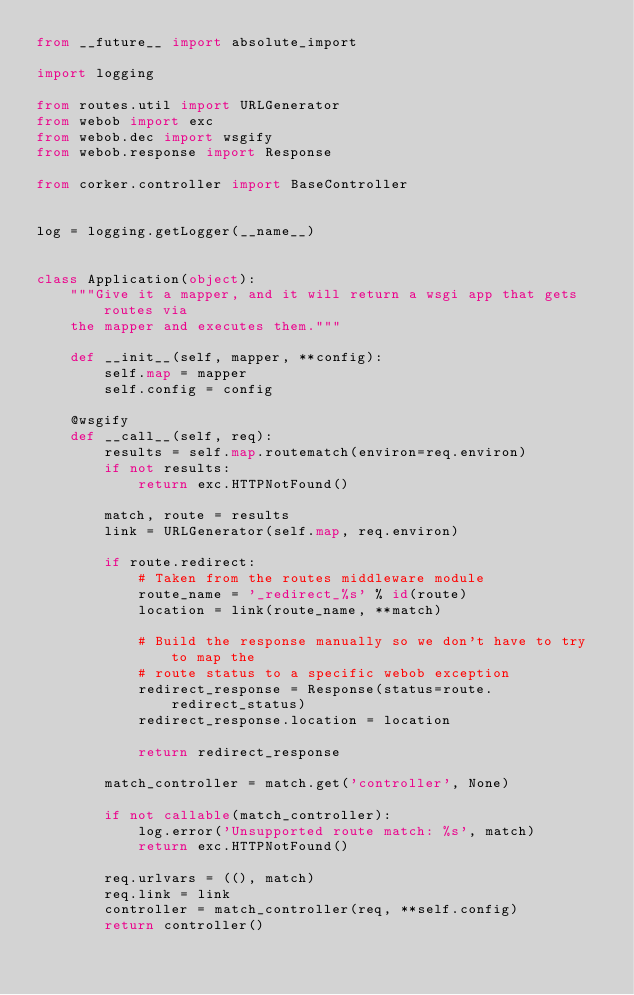<code> <loc_0><loc_0><loc_500><loc_500><_Python_>from __future__ import absolute_import

import logging

from routes.util import URLGenerator
from webob import exc
from webob.dec import wsgify
from webob.response import Response

from corker.controller import BaseController


log = logging.getLogger(__name__)


class Application(object):
    """Give it a mapper, and it will return a wsgi app that gets routes via
    the mapper and executes them."""

    def __init__(self, mapper, **config):
        self.map = mapper
        self.config = config

    @wsgify
    def __call__(self, req):
        results = self.map.routematch(environ=req.environ)
        if not results:
            return exc.HTTPNotFound()

        match, route = results
        link = URLGenerator(self.map, req.environ)

        if route.redirect:
            # Taken from the routes middleware module
            route_name = '_redirect_%s' % id(route)
            location = link(route_name, **match)

            # Build the response manually so we don't have to try to map the
            # route status to a specific webob exception
            redirect_response = Response(status=route.redirect_status)
            redirect_response.location = location

            return redirect_response

        match_controller = match.get('controller', None)

        if not callable(match_controller):
            log.error('Unsupported route match: %s', match)
            return exc.HTTPNotFound()

        req.urlvars = ((), match)
        req.link = link
        controller = match_controller(req, **self.config)
        return controller()
</code> 